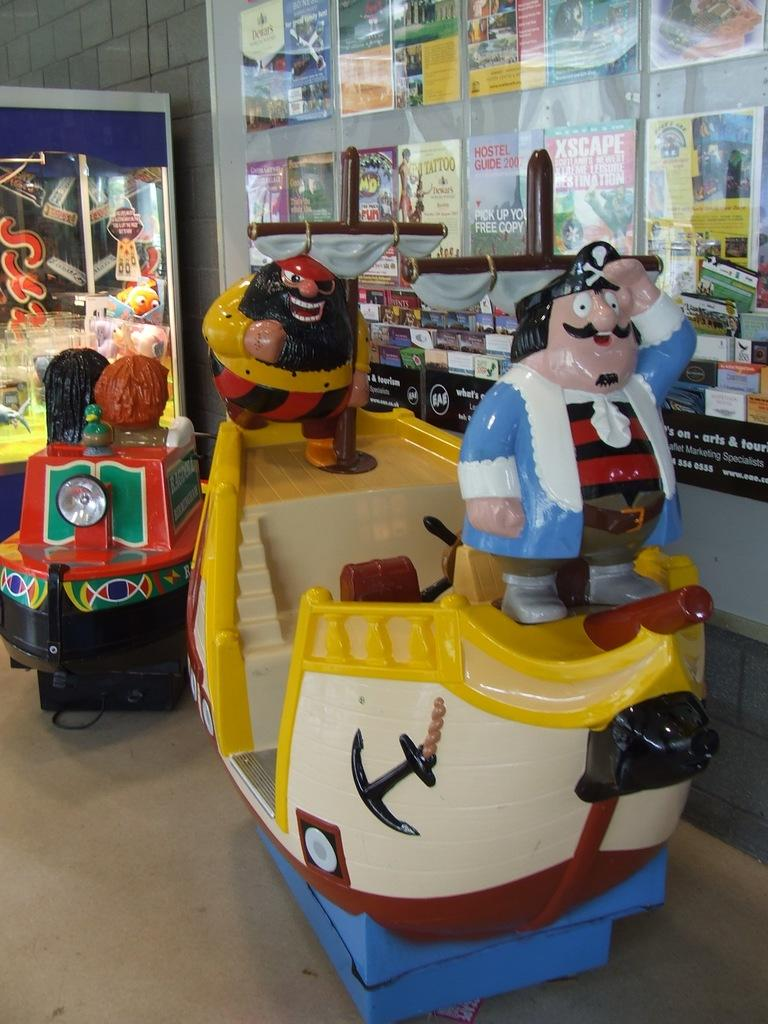<image>
Describe the image concisely. A children's ride has a magazine with the word XSCAPE behind it. 